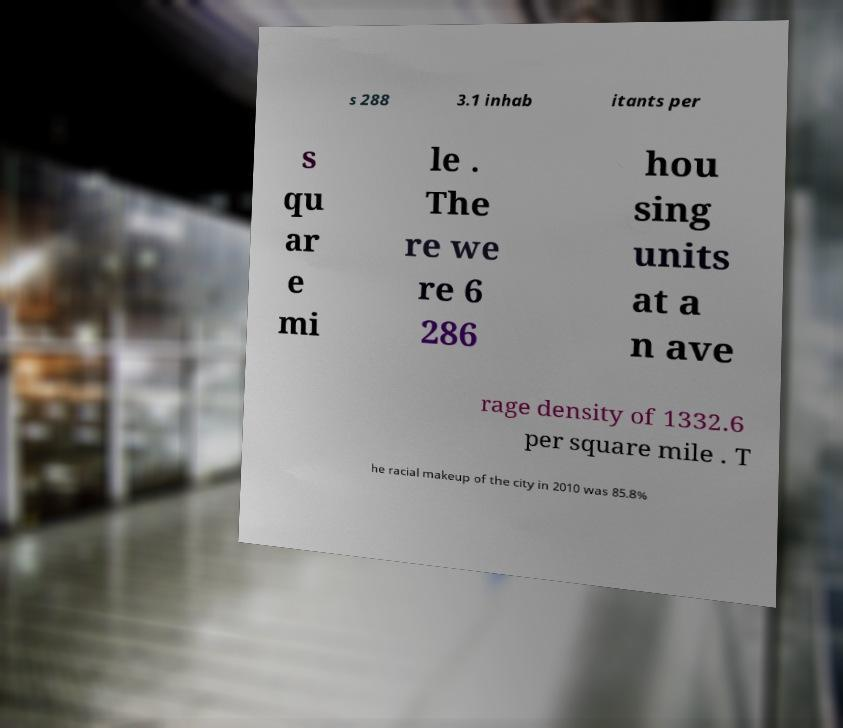What messages or text are displayed in this image? I need them in a readable, typed format. s 288 3.1 inhab itants per s qu ar e mi le . The re we re 6 286 hou sing units at a n ave rage density of 1332.6 per square mile . T he racial makeup of the city in 2010 was 85.8% 